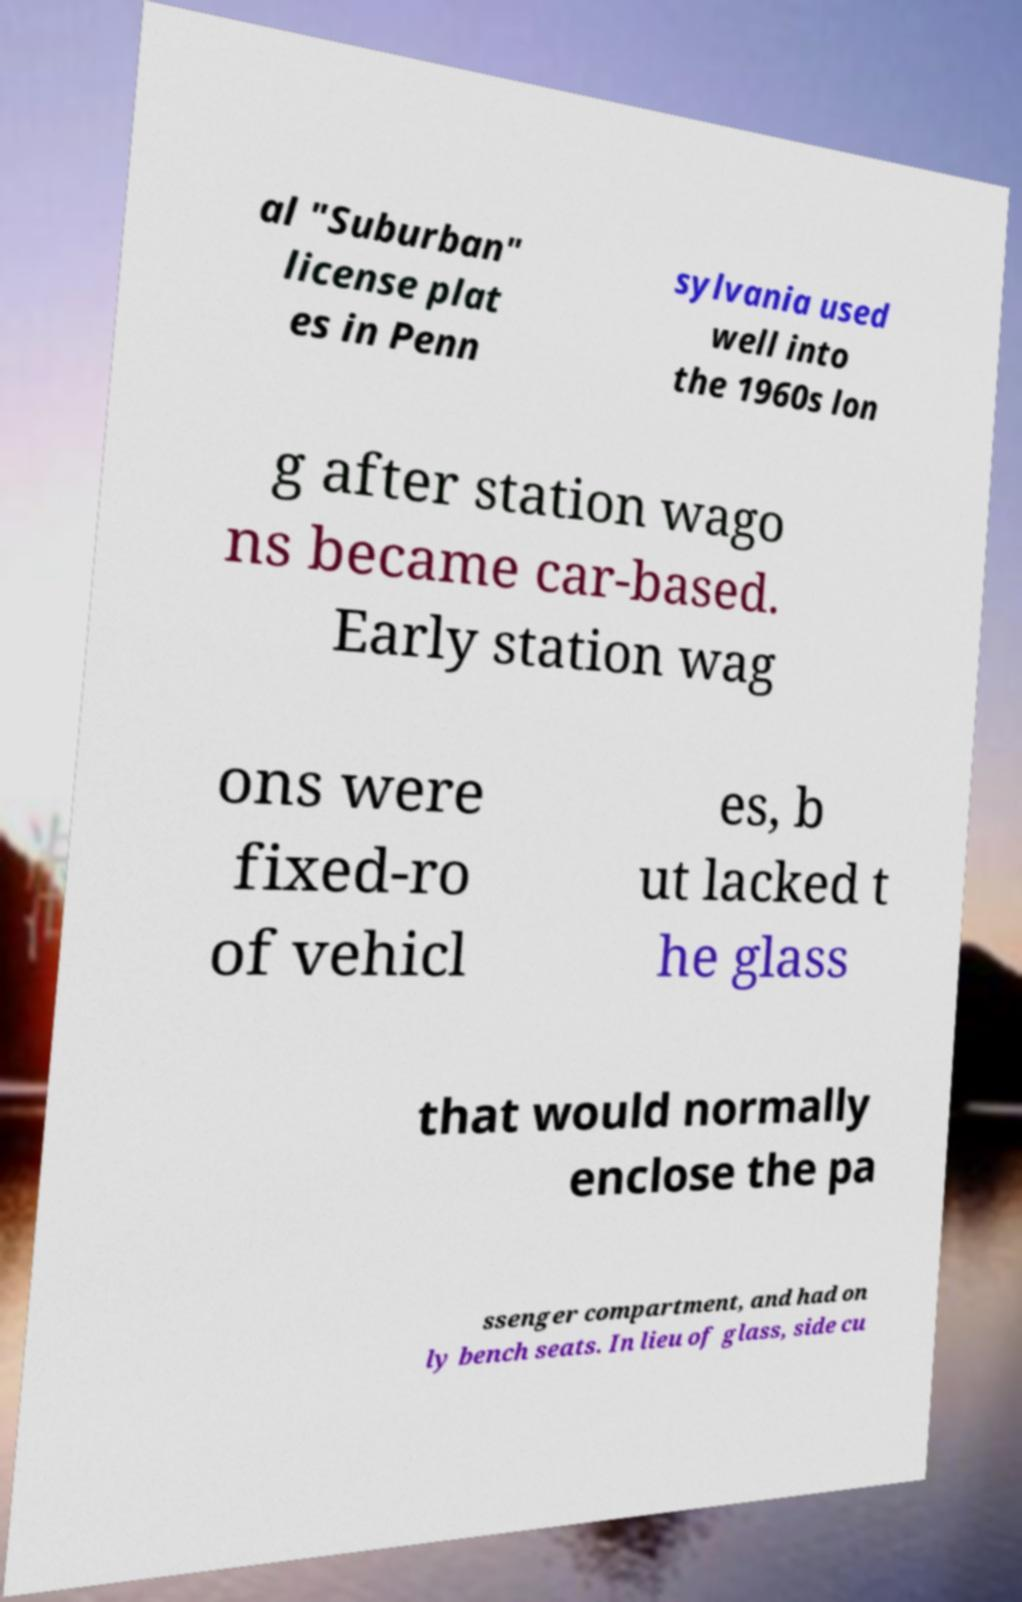I need the written content from this picture converted into text. Can you do that? al "Suburban" license plat es in Penn sylvania used well into the 1960s lon g after station wago ns became car-based. Early station wag ons were fixed-ro of vehicl es, b ut lacked t he glass that would normally enclose the pa ssenger compartment, and had on ly bench seats. In lieu of glass, side cu 